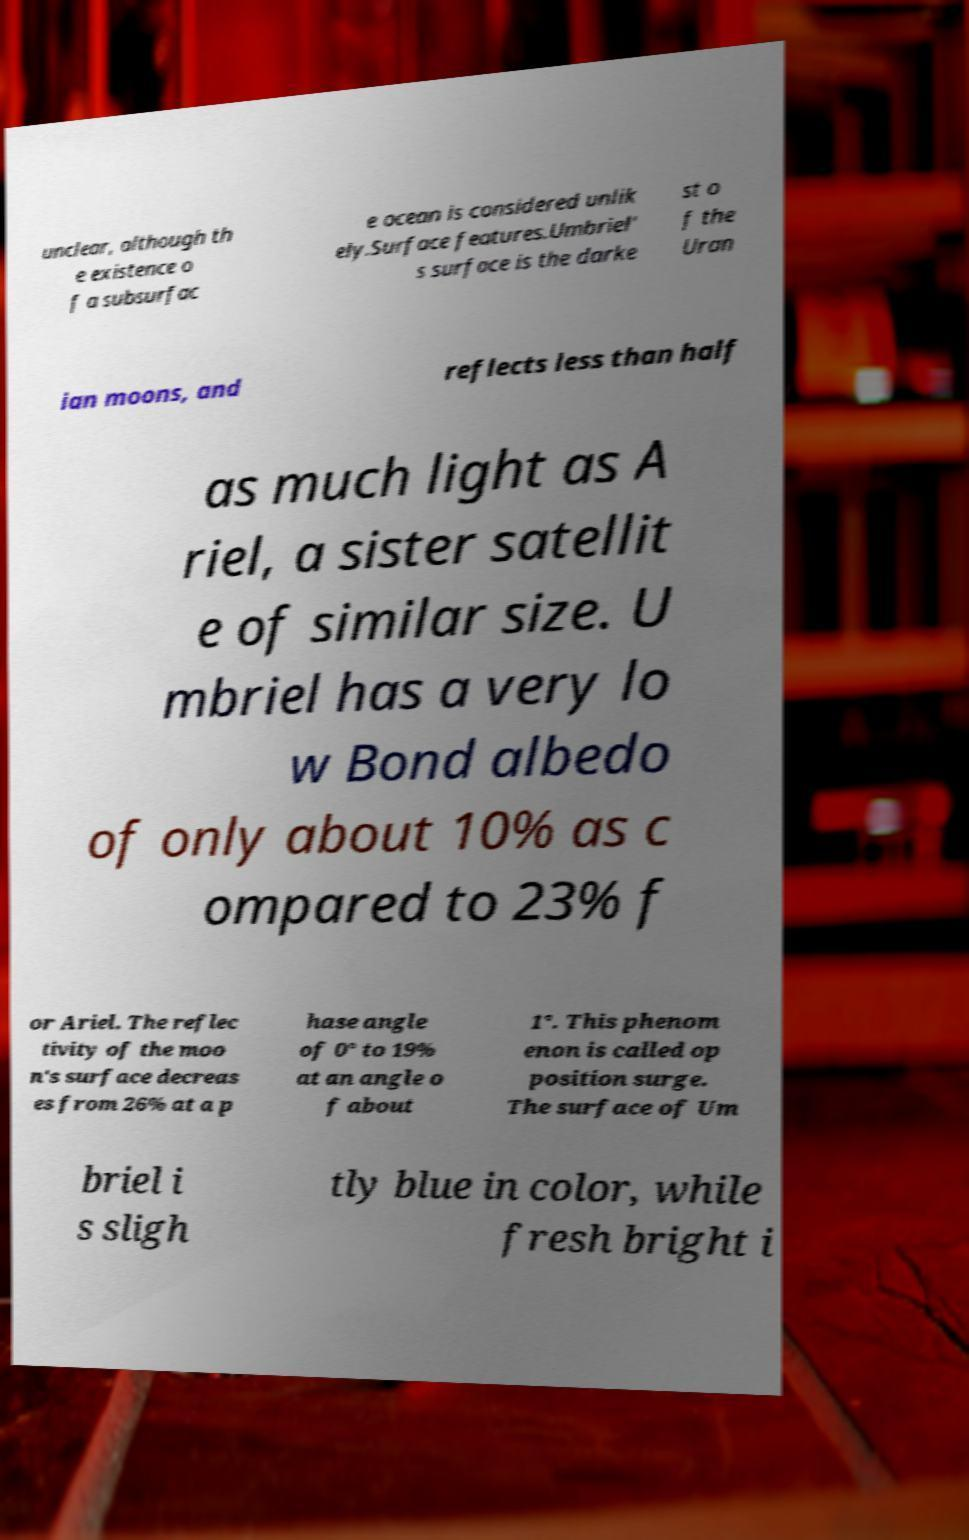Could you extract and type out the text from this image? unclear, although th e existence o f a subsurfac e ocean is considered unlik ely.Surface features.Umbriel' s surface is the darke st o f the Uran ian moons, and reflects less than half as much light as A riel, a sister satellit e of similar size. U mbriel has a very lo w Bond albedo of only about 10% as c ompared to 23% f or Ariel. The reflec tivity of the moo n's surface decreas es from 26% at a p hase angle of 0° to 19% at an angle o f about 1°. This phenom enon is called op position surge. The surface of Um briel i s sligh tly blue in color, while fresh bright i 